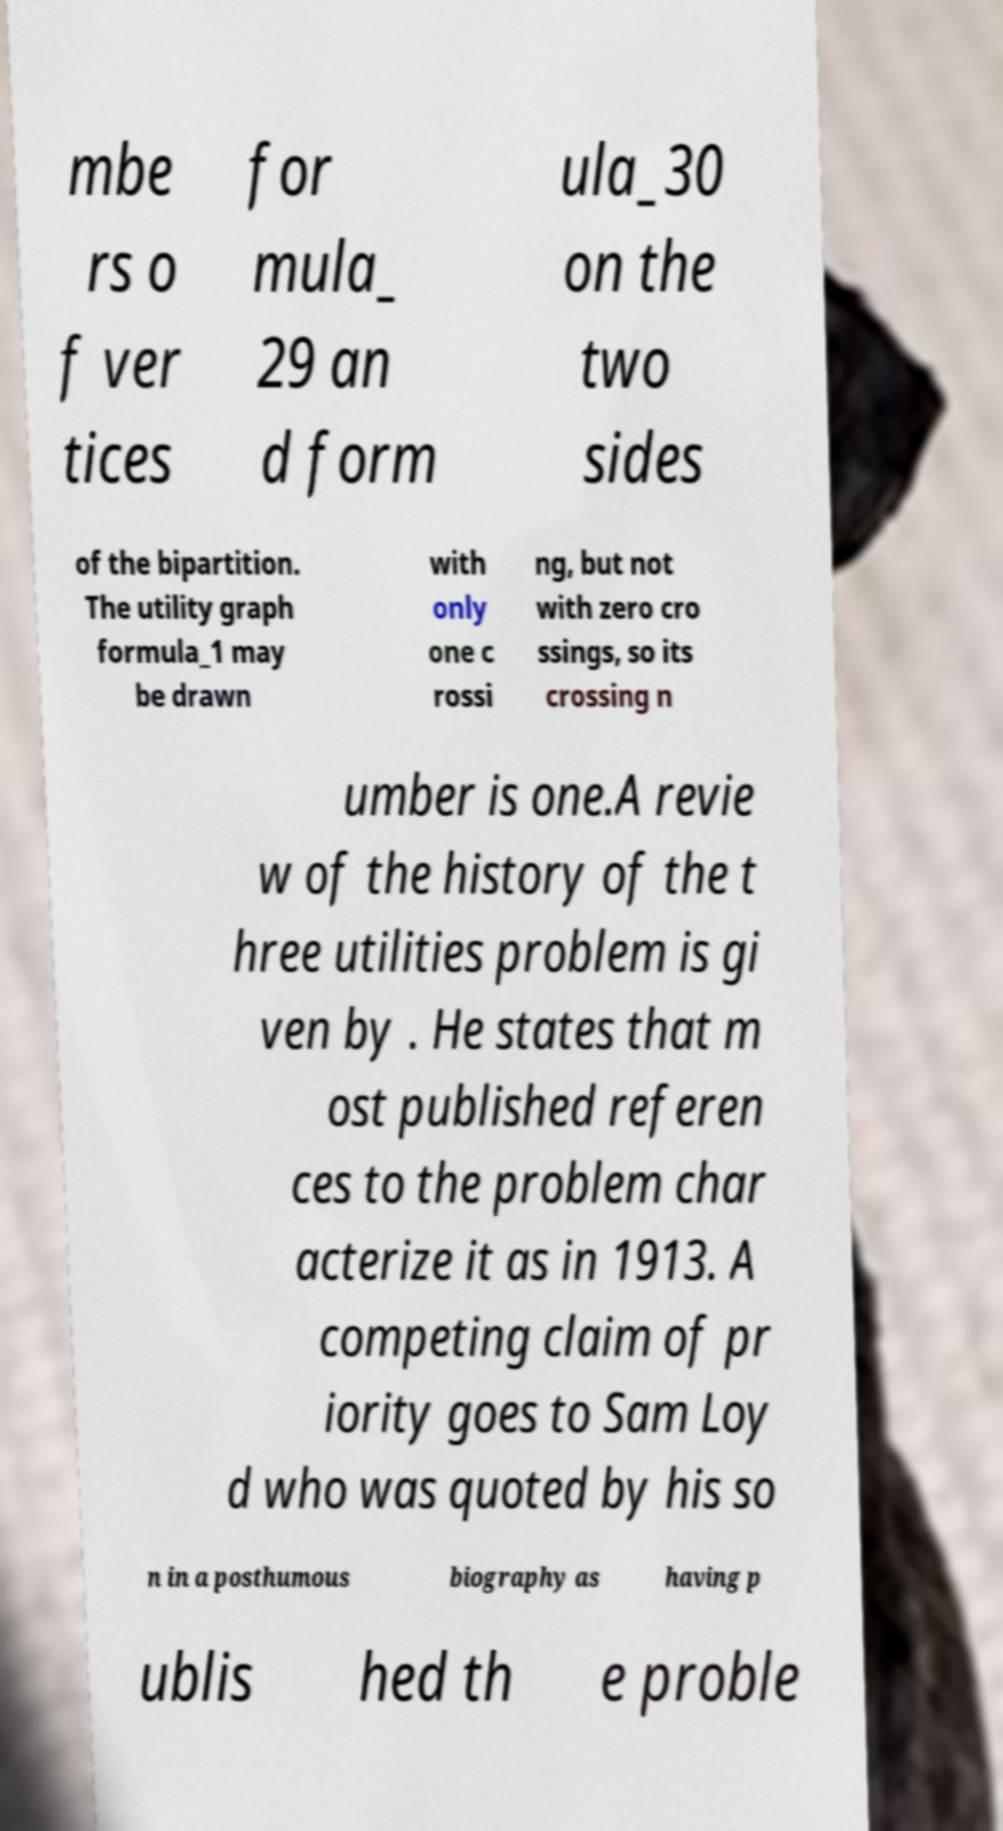Can you read and provide the text displayed in the image?This photo seems to have some interesting text. Can you extract and type it out for me? mbe rs o f ver tices for mula_ 29 an d form ula_30 on the two sides of the bipartition. The utility graph formula_1 may be drawn with only one c rossi ng, but not with zero cro ssings, so its crossing n umber is one.A revie w of the history of the t hree utilities problem is gi ven by . He states that m ost published referen ces to the problem char acterize it as in 1913. A competing claim of pr iority goes to Sam Loy d who was quoted by his so n in a posthumous biography as having p ublis hed th e proble 